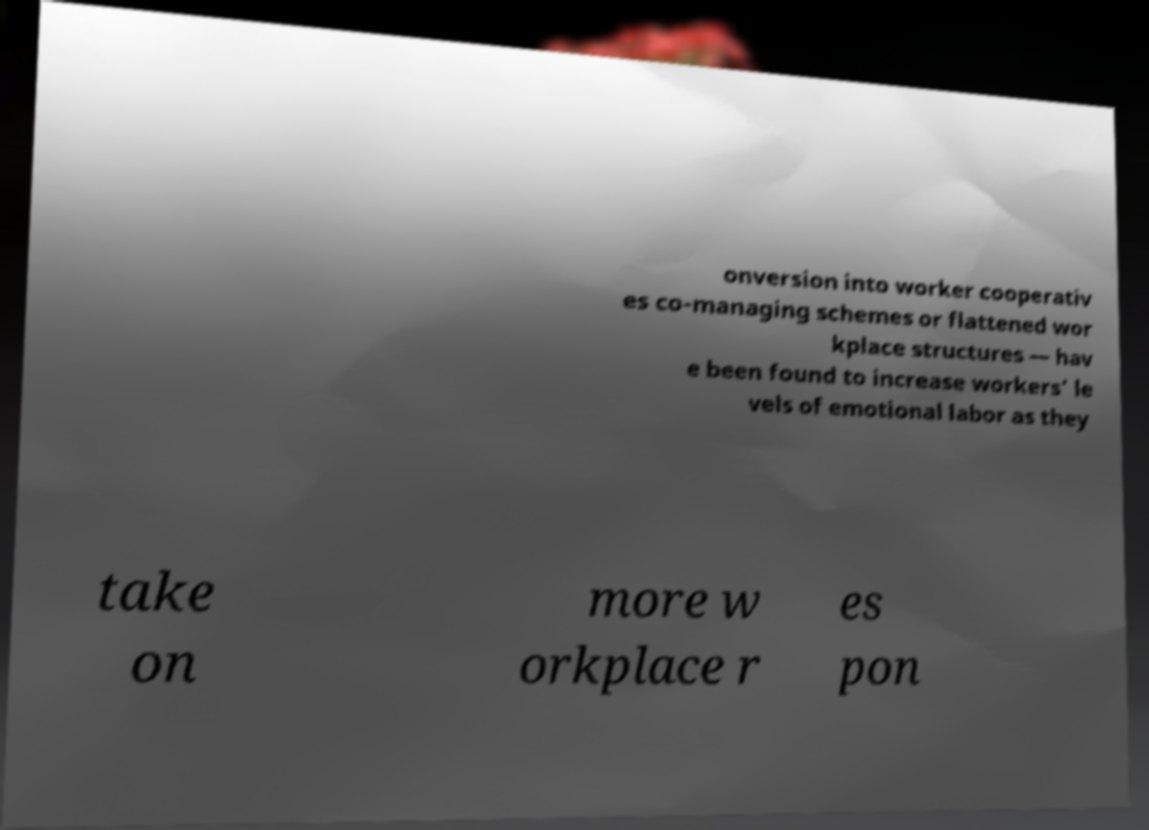Please read and relay the text visible in this image. What does it say? onversion into worker cooperativ es co-managing schemes or flattened wor kplace structures — hav e been found to increase workers’ le vels of emotional labor as they take on more w orkplace r es pon 